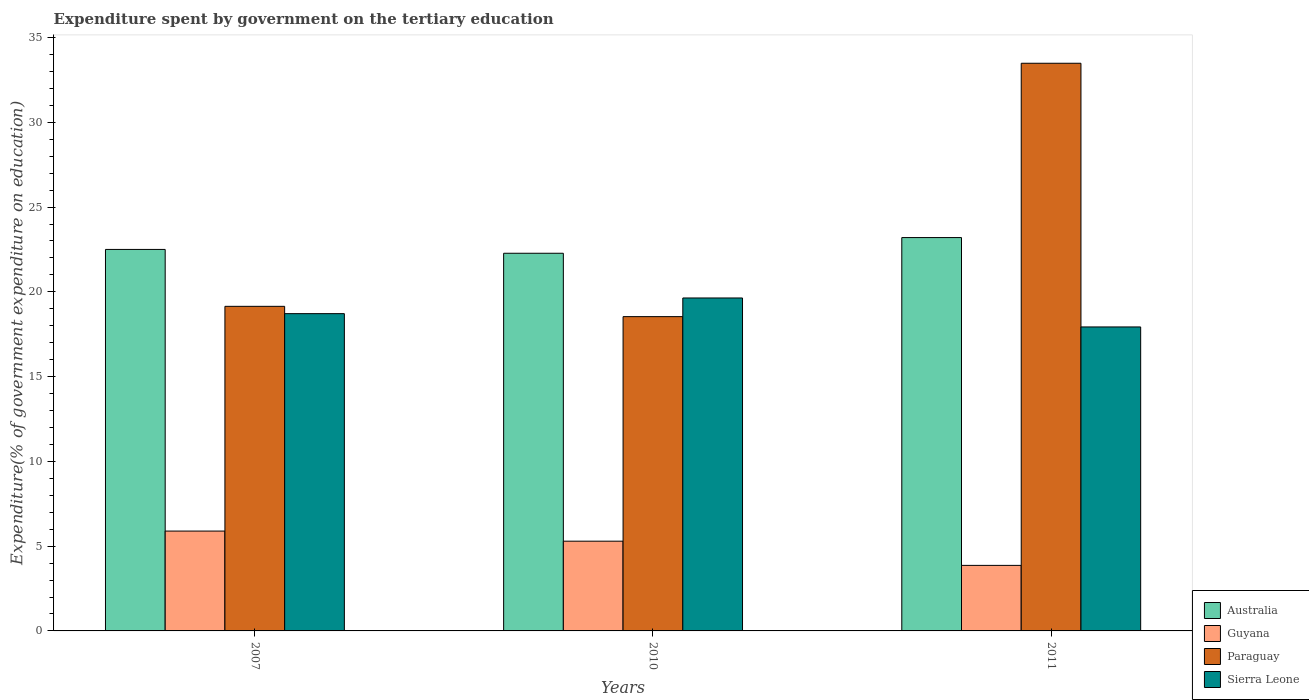Are the number of bars on each tick of the X-axis equal?
Provide a succinct answer. Yes. How many bars are there on the 3rd tick from the right?
Provide a succinct answer. 4. What is the label of the 2nd group of bars from the left?
Offer a terse response. 2010. What is the expenditure spent by government on the tertiary education in Paraguay in 2011?
Ensure brevity in your answer.  33.48. Across all years, what is the maximum expenditure spent by government on the tertiary education in Guyana?
Give a very brief answer. 5.89. Across all years, what is the minimum expenditure spent by government on the tertiary education in Sierra Leone?
Your answer should be very brief. 17.93. In which year was the expenditure spent by government on the tertiary education in Guyana maximum?
Your response must be concise. 2007. In which year was the expenditure spent by government on the tertiary education in Paraguay minimum?
Your answer should be very brief. 2010. What is the total expenditure spent by government on the tertiary education in Australia in the graph?
Ensure brevity in your answer.  67.98. What is the difference between the expenditure spent by government on the tertiary education in Paraguay in 2007 and that in 2011?
Your response must be concise. -14.34. What is the difference between the expenditure spent by government on the tertiary education in Guyana in 2011 and the expenditure spent by government on the tertiary education in Paraguay in 2010?
Ensure brevity in your answer.  -14.67. What is the average expenditure spent by government on the tertiary education in Sierra Leone per year?
Ensure brevity in your answer.  18.76. In the year 2007, what is the difference between the expenditure spent by government on the tertiary education in Guyana and expenditure spent by government on the tertiary education in Sierra Leone?
Give a very brief answer. -12.82. What is the ratio of the expenditure spent by government on the tertiary education in Paraguay in 2007 to that in 2011?
Your answer should be compact. 0.57. Is the expenditure spent by government on the tertiary education in Guyana in 2007 less than that in 2010?
Your answer should be very brief. No. What is the difference between the highest and the second highest expenditure spent by government on the tertiary education in Australia?
Your response must be concise. 0.7. What is the difference between the highest and the lowest expenditure spent by government on the tertiary education in Sierra Leone?
Offer a terse response. 1.71. In how many years, is the expenditure spent by government on the tertiary education in Sierra Leone greater than the average expenditure spent by government on the tertiary education in Sierra Leone taken over all years?
Give a very brief answer. 1. Is it the case that in every year, the sum of the expenditure spent by government on the tertiary education in Paraguay and expenditure spent by government on the tertiary education in Australia is greater than the sum of expenditure spent by government on the tertiary education in Sierra Leone and expenditure spent by government on the tertiary education in Guyana?
Your answer should be very brief. Yes. What does the 2nd bar from the left in 2007 represents?
Your answer should be very brief. Guyana. What does the 3rd bar from the right in 2010 represents?
Your response must be concise. Guyana. How many bars are there?
Offer a terse response. 12. What is the difference between two consecutive major ticks on the Y-axis?
Provide a succinct answer. 5. Are the values on the major ticks of Y-axis written in scientific E-notation?
Give a very brief answer. No. Does the graph contain any zero values?
Offer a terse response. No. Does the graph contain grids?
Your answer should be compact. No. Where does the legend appear in the graph?
Keep it short and to the point. Bottom right. How are the legend labels stacked?
Provide a short and direct response. Vertical. What is the title of the graph?
Give a very brief answer. Expenditure spent by government on the tertiary education. Does "Latin America(all income levels)" appear as one of the legend labels in the graph?
Keep it short and to the point. No. What is the label or title of the X-axis?
Give a very brief answer. Years. What is the label or title of the Y-axis?
Give a very brief answer. Expenditure(% of government expenditure on education). What is the Expenditure(% of government expenditure on education) in Australia in 2007?
Make the answer very short. 22.5. What is the Expenditure(% of government expenditure on education) in Guyana in 2007?
Your answer should be compact. 5.89. What is the Expenditure(% of government expenditure on education) of Paraguay in 2007?
Offer a terse response. 19.15. What is the Expenditure(% of government expenditure on education) of Sierra Leone in 2007?
Your answer should be compact. 18.71. What is the Expenditure(% of government expenditure on education) of Australia in 2010?
Your response must be concise. 22.28. What is the Expenditure(% of government expenditure on education) of Guyana in 2010?
Keep it short and to the point. 5.29. What is the Expenditure(% of government expenditure on education) in Paraguay in 2010?
Give a very brief answer. 18.54. What is the Expenditure(% of government expenditure on education) in Sierra Leone in 2010?
Your answer should be compact. 19.64. What is the Expenditure(% of government expenditure on education) of Australia in 2011?
Your answer should be compact. 23.2. What is the Expenditure(% of government expenditure on education) of Guyana in 2011?
Your answer should be very brief. 3.87. What is the Expenditure(% of government expenditure on education) in Paraguay in 2011?
Provide a short and direct response. 33.48. What is the Expenditure(% of government expenditure on education) of Sierra Leone in 2011?
Your answer should be very brief. 17.93. Across all years, what is the maximum Expenditure(% of government expenditure on education) of Australia?
Ensure brevity in your answer.  23.2. Across all years, what is the maximum Expenditure(% of government expenditure on education) of Guyana?
Your response must be concise. 5.89. Across all years, what is the maximum Expenditure(% of government expenditure on education) of Paraguay?
Provide a succinct answer. 33.48. Across all years, what is the maximum Expenditure(% of government expenditure on education) of Sierra Leone?
Ensure brevity in your answer.  19.64. Across all years, what is the minimum Expenditure(% of government expenditure on education) in Australia?
Offer a very short reply. 22.28. Across all years, what is the minimum Expenditure(% of government expenditure on education) in Guyana?
Make the answer very short. 3.87. Across all years, what is the minimum Expenditure(% of government expenditure on education) of Paraguay?
Ensure brevity in your answer.  18.54. Across all years, what is the minimum Expenditure(% of government expenditure on education) in Sierra Leone?
Your answer should be compact. 17.93. What is the total Expenditure(% of government expenditure on education) of Australia in the graph?
Your response must be concise. 67.98. What is the total Expenditure(% of government expenditure on education) of Guyana in the graph?
Provide a short and direct response. 15.05. What is the total Expenditure(% of government expenditure on education) in Paraguay in the graph?
Ensure brevity in your answer.  71.17. What is the total Expenditure(% of government expenditure on education) in Sierra Leone in the graph?
Your answer should be compact. 56.28. What is the difference between the Expenditure(% of government expenditure on education) in Australia in 2007 and that in 2010?
Offer a very short reply. 0.23. What is the difference between the Expenditure(% of government expenditure on education) of Guyana in 2007 and that in 2010?
Offer a terse response. 0.6. What is the difference between the Expenditure(% of government expenditure on education) in Paraguay in 2007 and that in 2010?
Provide a short and direct response. 0.61. What is the difference between the Expenditure(% of government expenditure on education) in Sierra Leone in 2007 and that in 2010?
Your answer should be compact. -0.92. What is the difference between the Expenditure(% of government expenditure on education) in Australia in 2007 and that in 2011?
Provide a succinct answer. -0.7. What is the difference between the Expenditure(% of government expenditure on education) of Guyana in 2007 and that in 2011?
Provide a succinct answer. 2.02. What is the difference between the Expenditure(% of government expenditure on education) in Paraguay in 2007 and that in 2011?
Your answer should be compact. -14.34. What is the difference between the Expenditure(% of government expenditure on education) of Sierra Leone in 2007 and that in 2011?
Provide a succinct answer. 0.78. What is the difference between the Expenditure(% of government expenditure on education) in Australia in 2010 and that in 2011?
Give a very brief answer. -0.93. What is the difference between the Expenditure(% of government expenditure on education) in Guyana in 2010 and that in 2011?
Ensure brevity in your answer.  1.43. What is the difference between the Expenditure(% of government expenditure on education) of Paraguay in 2010 and that in 2011?
Provide a succinct answer. -14.95. What is the difference between the Expenditure(% of government expenditure on education) in Sierra Leone in 2010 and that in 2011?
Your answer should be very brief. 1.71. What is the difference between the Expenditure(% of government expenditure on education) in Australia in 2007 and the Expenditure(% of government expenditure on education) in Guyana in 2010?
Your answer should be compact. 17.21. What is the difference between the Expenditure(% of government expenditure on education) of Australia in 2007 and the Expenditure(% of government expenditure on education) of Paraguay in 2010?
Keep it short and to the point. 3.96. What is the difference between the Expenditure(% of government expenditure on education) in Australia in 2007 and the Expenditure(% of government expenditure on education) in Sierra Leone in 2010?
Provide a succinct answer. 2.86. What is the difference between the Expenditure(% of government expenditure on education) of Guyana in 2007 and the Expenditure(% of government expenditure on education) of Paraguay in 2010?
Your answer should be compact. -12.65. What is the difference between the Expenditure(% of government expenditure on education) in Guyana in 2007 and the Expenditure(% of government expenditure on education) in Sierra Leone in 2010?
Ensure brevity in your answer.  -13.75. What is the difference between the Expenditure(% of government expenditure on education) of Paraguay in 2007 and the Expenditure(% of government expenditure on education) of Sierra Leone in 2010?
Ensure brevity in your answer.  -0.49. What is the difference between the Expenditure(% of government expenditure on education) in Australia in 2007 and the Expenditure(% of government expenditure on education) in Guyana in 2011?
Your answer should be compact. 18.64. What is the difference between the Expenditure(% of government expenditure on education) of Australia in 2007 and the Expenditure(% of government expenditure on education) of Paraguay in 2011?
Provide a succinct answer. -10.98. What is the difference between the Expenditure(% of government expenditure on education) of Australia in 2007 and the Expenditure(% of government expenditure on education) of Sierra Leone in 2011?
Give a very brief answer. 4.57. What is the difference between the Expenditure(% of government expenditure on education) in Guyana in 2007 and the Expenditure(% of government expenditure on education) in Paraguay in 2011?
Make the answer very short. -27.59. What is the difference between the Expenditure(% of government expenditure on education) of Guyana in 2007 and the Expenditure(% of government expenditure on education) of Sierra Leone in 2011?
Keep it short and to the point. -12.04. What is the difference between the Expenditure(% of government expenditure on education) in Paraguay in 2007 and the Expenditure(% of government expenditure on education) in Sierra Leone in 2011?
Give a very brief answer. 1.22. What is the difference between the Expenditure(% of government expenditure on education) of Australia in 2010 and the Expenditure(% of government expenditure on education) of Guyana in 2011?
Your answer should be compact. 18.41. What is the difference between the Expenditure(% of government expenditure on education) of Australia in 2010 and the Expenditure(% of government expenditure on education) of Paraguay in 2011?
Your answer should be compact. -11.21. What is the difference between the Expenditure(% of government expenditure on education) in Australia in 2010 and the Expenditure(% of government expenditure on education) in Sierra Leone in 2011?
Ensure brevity in your answer.  4.35. What is the difference between the Expenditure(% of government expenditure on education) in Guyana in 2010 and the Expenditure(% of government expenditure on education) in Paraguay in 2011?
Give a very brief answer. -28.19. What is the difference between the Expenditure(% of government expenditure on education) in Guyana in 2010 and the Expenditure(% of government expenditure on education) in Sierra Leone in 2011?
Provide a succinct answer. -12.64. What is the difference between the Expenditure(% of government expenditure on education) of Paraguay in 2010 and the Expenditure(% of government expenditure on education) of Sierra Leone in 2011?
Give a very brief answer. 0.61. What is the average Expenditure(% of government expenditure on education) in Australia per year?
Your response must be concise. 22.66. What is the average Expenditure(% of government expenditure on education) of Guyana per year?
Your answer should be compact. 5.02. What is the average Expenditure(% of government expenditure on education) of Paraguay per year?
Your answer should be very brief. 23.72. What is the average Expenditure(% of government expenditure on education) in Sierra Leone per year?
Your response must be concise. 18.76. In the year 2007, what is the difference between the Expenditure(% of government expenditure on education) of Australia and Expenditure(% of government expenditure on education) of Guyana?
Provide a succinct answer. 16.61. In the year 2007, what is the difference between the Expenditure(% of government expenditure on education) in Australia and Expenditure(% of government expenditure on education) in Paraguay?
Your response must be concise. 3.36. In the year 2007, what is the difference between the Expenditure(% of government expenditure on education) in Australia and Expenditure(% of government expenditure on education) in Sierra Leone?
Your answer should be very brief. 3.79. In the year 2007, what is the difference between the Expenditure(% of government expenditure on education) of Guyana and Expenditure(% of government expenditure on education) of Paraguay?
Offer a very short reply. -13.26. In the year 2007, what is the difference between the Expenditure(% of government expenditure on education) in Guyana and Expenditure(% of government expenditure on education) in Sierra Leone?
Your response must be concise. -12.82. In the year 2007, what is the difference between the Expenditure(% of government expenditure on education) of Paraguay and Expenditure(% of government expenditure on education) of Sierra Leone?
Keep it short and to the point. 0.43. In the year 2010, what is the difference between the Expenditure(% of government expenditure on education) of Australia and Expenditure(% of government expenditure on education) of Guyana?
Offer a very short reply. 16.98. In the year 2010, what is the difference between the Expenditure(% of government expenditure on education) in Australia and Expenditure(% of government expenditure on education) in Paraguay?
Offer a very short reply. 3.74. In the year 2010, what is the difference between the Expenditure(% of government expenditure on education) in Australia and Expenditure(% of government expenditure on education) in Sierra Leone?
Ensure brevity in your answer.  2.64. In the year 2010, what is the difference between the Expenditure(% of government expenditure on education) in Guyana and Expenditure(% of government expenditure on education) in Paraguay?
Offer a very short reply. -13.24. In the year 2010, what is the difference between the Expenditure(% of government expenditure on education) of Guyana and Expenditure(% of government expenditure on education) of Sierra Leone?
Provide a short and direct response. -14.35. In the year 2010, what is the difference between the Expenditure(% of government expenditure on education) of Paraguay and Expenditure(% of government expenditure on education) of Sierra Leone?
Your answer should be compact. -1.1. In the year 2011, what is the difference between the Expenditure(% of government expenditure on education) in Australia and Expenditure(% of government expenditure on education) in Guyana?
Offer a very short reply. 19.34. In the year 2011, what is the difference between the Expenditure(% of government expenditure on education) in Australia and Expenditure(% of government expenditure on education) in Paraguay?
Make the answer very short. -10.28. In the year 2011, what is the difference between the Expenditure(% of government expenditure on education) of Australia and Expenditure(% of government expenditure on education) of Sierra Leone?
Offer a very short reply. 5.27. In the year 2011, what is the difference between the Expenditure(% of government expenditure on education) in Guyana and Expenditure(% of government expenditure on education) in Paraguay?
Offer a terse response. -29.62. In the year 2011, what is the difference between the Expenditure(% of government expenditure on education) in Guyana and Expenditure(% of government expenditure on education) in Sierra Leone?
Your answer should be compact. -14.06. In the year 2011, what is the difference between the Expenditure(% of government expenditure on education) in Paraguay and Expenditure(% of government expenditure on education) in Sierra Leone?
Your answer should be compact. 15.55. What is the ratio of the Expenditure(% of government expenditure on education) in Guyana in 2007 to that in 2010?
Your response must be concise. 1.11. What is the ratio of the Expenditure(% of government expenditure on education) in Paraguay in 2007 to that in 2010?
Offer a very short reply. 1.03. What is the ratio of the Expenditure(% of government expenditure on education) of Sierra Leone in 2007 to that in 2010?
Offer a terse response. 0.95. What is the ratio of the Expenditure(% of government expenditure on education) in Australia in 2007 to that in 2011?
Your response must be concise. 0.97. What is the ratio of the Expenditure(% of government expenditure on education) in Guyana in 2007 to that in 2011?
Your answer should be very brief. 1.52. What is the ratio of the Expenditure(% of government expenditure on education) in Paraguay in 2007 to that in 2011?
Offer a terse response. 0.57. What is the ratio of the Expenditure(% of government expenditure on education) in Sierra Leone in 2007 to that in 2011?
Keep it short and to the point. 1.04. What is the ratio of the Expenditure(% of government expenditure on education) of Australia in 2010 to that in 2011?
Provide a succinct answer. 0.96. What is the ratio of the Expenditure(% of government expenditure on education) in Guyana in 2010 to that in 2011?
Your answer should be very brief. 1.37. What is the ratio of the Expenditure(% of government expenditure on education) of Paraguay in 2010 to that in 2011?
Ensure brevity in your answer.  0.55. What is the ratio of the Expenditure(% of government expenditure on education) of Sierra Leone in 2010 to that in 2011?
Provide a short and direct response. 1.1. What is the difference between the highest and the second highest Expenditure(% of government expenditure on education) in Australia?
Make the answer very short. 0.7. What is the difference between the highest and the second highest Expenditure(% of government expenditure on education) of Guyana?
Keep it short and to the point. 0.6. What is the difference between the highest and the second highest Expenditure(% of government expenditure on education) in Paraguay?
Provide a succinct answer. 14.34. What is the difference between the highest and the second highest Expenditure(% of government expenditure on education) of Sierra Leone?
Make the answer very short. 0.92. What is the difference between the highest and the lowest Expenditure(% of government expenditure on education) of Australia?
Make the answer very short. 0.93. What is the difference between the highest and the lowest Expenditure(% of government expenditure on education) of Guyana?
Ensure brevity in your answer.  2.02. What is the difference between the highest and the lowest Expenditure(% of government expenditure on education) in Paraguay?
Ensure brevity in your answer.  14.95. What is the difference between the highest and the lowest Expenditure(% of government expenditure on education) in Sierra Leone?
Keep it short and to the point. 1.71. 